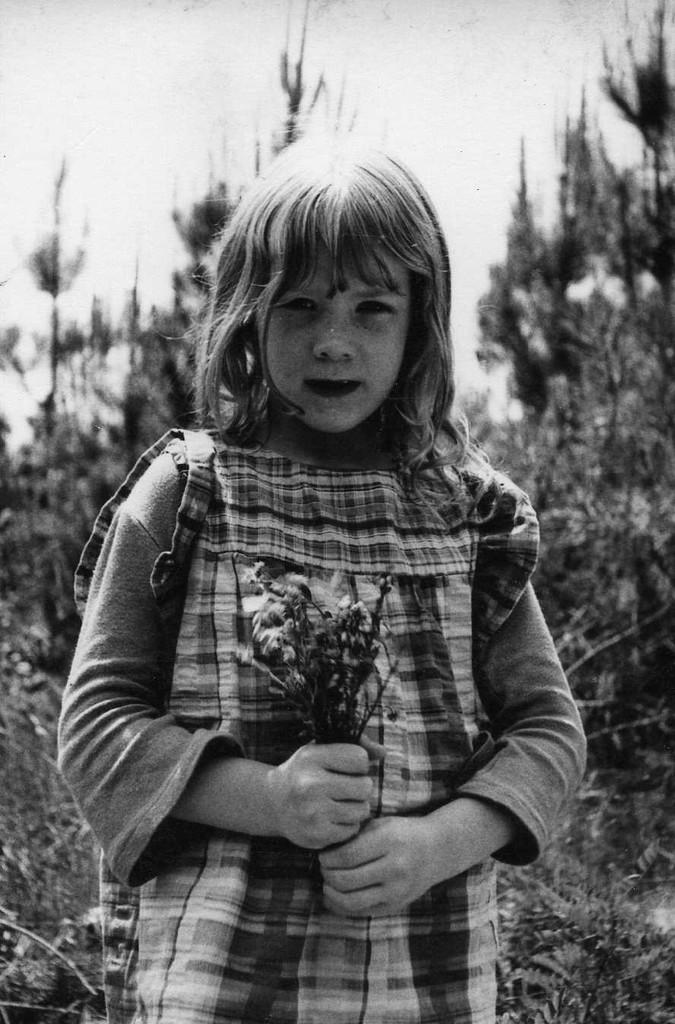Who is the main subject in the image? There is a girl in the image. What is the girl holding in the image? The girl is holding flowers. What can be seen in the background of the image? There are trees visible in the background of the image. What type of camera can be seen in the girl's hand in the image? There is no camera visible in the girl's hand in the image; she is holding flowers. What type of salt is sprinkled on the flowers in the image? There is no salt present in the image; the girl is holding flowers. 